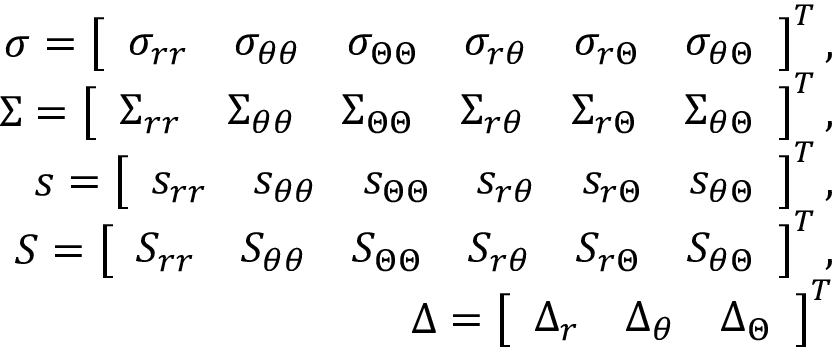Convert formula to latex. <formula><loc_0><loc_0><loc_500><loc_500>\begin{array} { r } { \sigma = \left [ \begin{array} { l l l l l l } { \sigma _ { r r } } & { \sigma _ { \theta \theta } } & { \sigma _ { \Theta \Theta } } & { \sigma _ { r \theta } } & { \sigma _ { r \Theta } } & { \sigma _ { \theta \Theta } } \end{array} \right ] ^ { T } , } \\ { \Sigma = \left [ \begin{array} { l l l l l l } { \Sigma _ { r r } } & { \Sigma _ { \theta \theta } } & { \Sigma _ { \Theta \Theta } } & { \Sigma _ { r \theta } } & { \Sigma _ { r \Theta } } & { \Sigma _ { \theta \Theta } } \end{array} \right ] ^ { T } , } \\ { s = \left [ \begin{array} { l l l l l l } { s _ { r r } } & { s _ { \theta \theta } } & { s _ { \Theta \Theta } } & { s _ { r \theta } } & { s _ { r \Theta } } & { s _ { \theta \Theta } } \end{array} \right ] ^ { T } , } \\ { S = \left [ \begin{array} { l l l l l l } { S _ { r r } } & { S _ { \theta \theta } } & { S _ { \Theta \Theta } } & { S _ { r \theta } } & { S _ { r \Theta } } & { S _ { \theta \Theta } } \end{array} \right ] ^ { T } , } \\ { \Delta = \left [ \begin{array} { l l l } { \Delta _ { r } } & { \Delta _ { \theta } } & { \Delta _ { \Theta } } \end{array} \right ] ^ { T } } \end{array}</formula> 